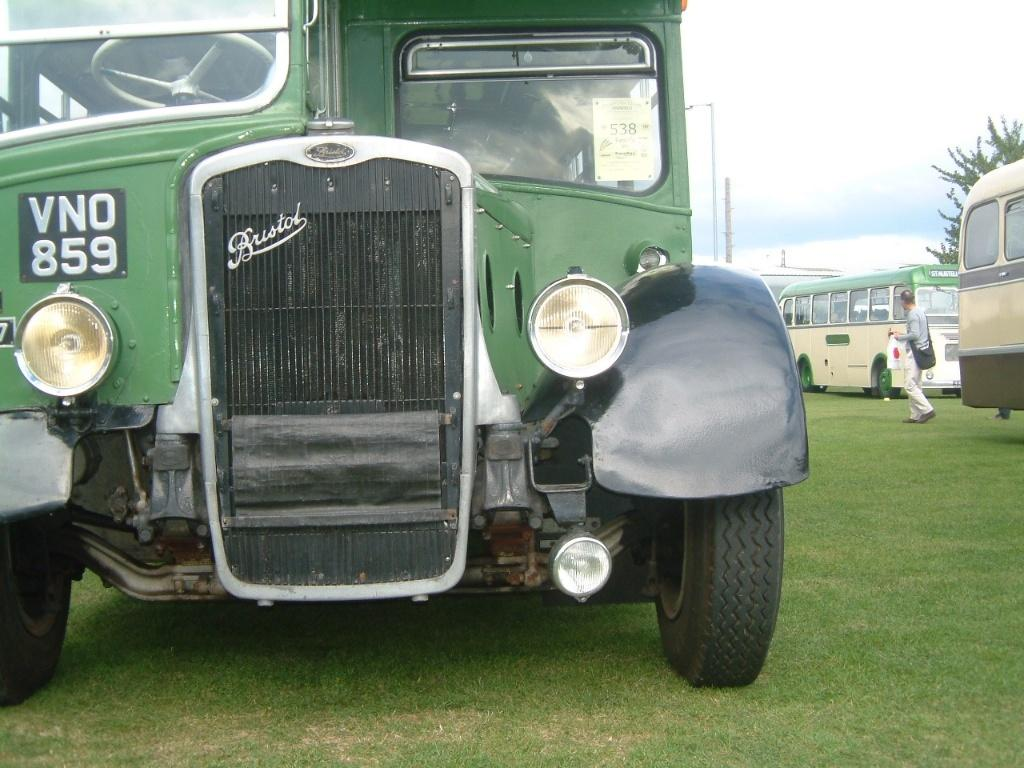What types of vehicles are in the image? There are vehicles in the image, but the specific types are not mentioned. What can be seen in the distance behind the vehicles? There is a building, trees, and other objects in the background of the image. What is the ground surface like at the bottom of the image? There is grass at the bottom of the image. What is the tax on the vehicles in the image? There is no mention of tax in the image or the provided facts. 